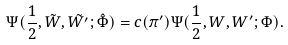<formula> <loc_0><loc_0><loc_500><loc_500>\Psi ( \frac { 1 } { 2 } , \tilde { W } , \tilde { W ^ { \prime } } ; \hat { \Phi } ) = c ( \pi ^ { \prime } ) \Psi ( \frac { 1 } { 2 } , W , W ^ { \prime } ; \Phi ) .</formula> 